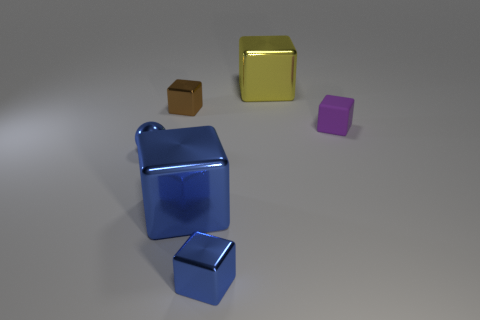Do the tiny matte block and the metal ball have the same color?
Provide a succinct answer. No. There is a object behind the brown block; how big is it?
Provide a succinct answer. Large. What number of small blue metallic objects have the same shape as the big blue object?
Give a very brief answer. 1. What is the shape of the big blue object that is the same material as the yellow thing?
Give a very brief answer. Cube. How many purple things are small rubber blocks or tiny metallic balls?
Your response must be concise. 1. There is a metal ball; are there any cubes behind it?
Offer a terse response. Yes. Is the shape of the metal object that is in front of the large blue thing the same as the thing that is behind the brown metal object?
Provide a succinct answer. Yes. There is a small blue thing that is the same shape as the large blue object; what is its material?
Ensure brevity in your answer.  Metal. What number of balls are small rubber objects or small things?
Give a very brief answer. 1. What number of large things are made of the same material as the tiny brown thing?
Ensure brevity in your answer.  2. 